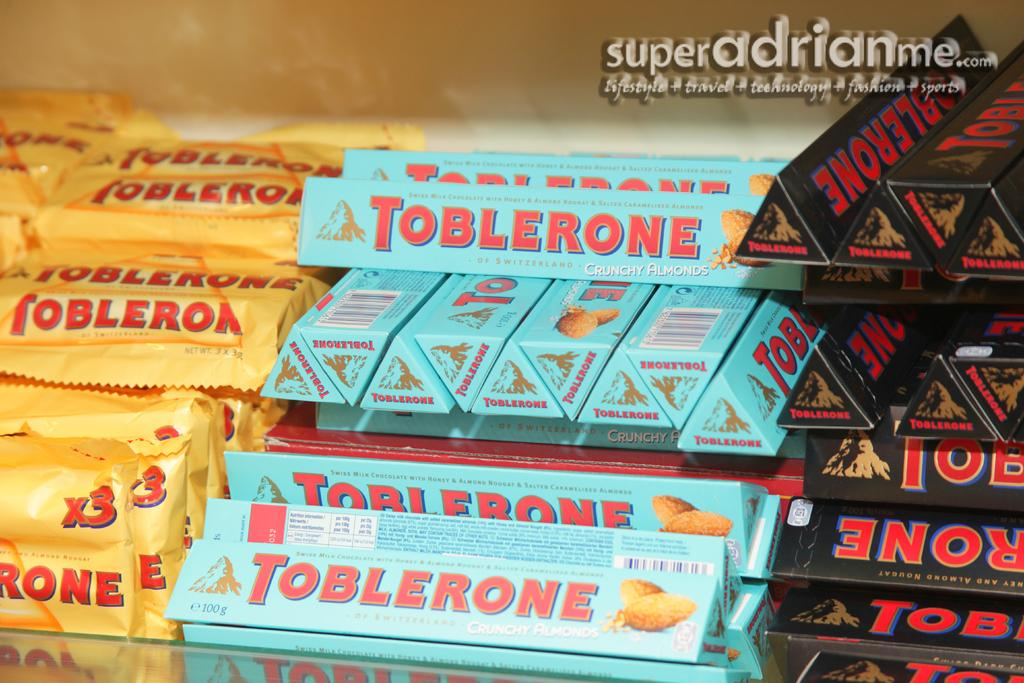Provide a one-sentence caption for the provided image. A display of toblerones in blue, black and yellow. 